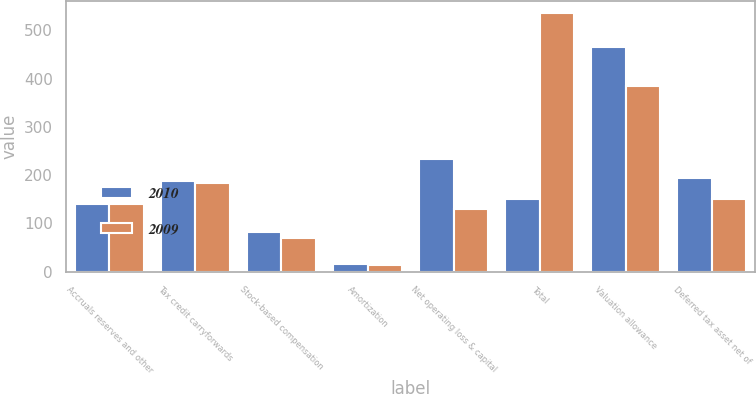Convert chart to OTSL. <chart><loc_0><loc_0><loc_500><loc_500><stacked_bar_chart><ecel><fcel>Accruals reserves and other<fcel>Tax credit carryforwards<fcel>Stock-based compensation<fcel>Amortization<fcel>Net operating loss & capital<fcel>Total<fcel>Valuation allowance<fcel>Deferred tax asset net of<nl><fcel>2010<fcel>141<fcel>188<fcel>81<fcel>16<fcel>233<fcel>151<fcel>466<fcel>193<nl><fcel>2009<fcel>140<fcel>183<fcel>69<fcel>14<fcel>129<fcel>535<fcel>384<fcel>151<nl></chart> 